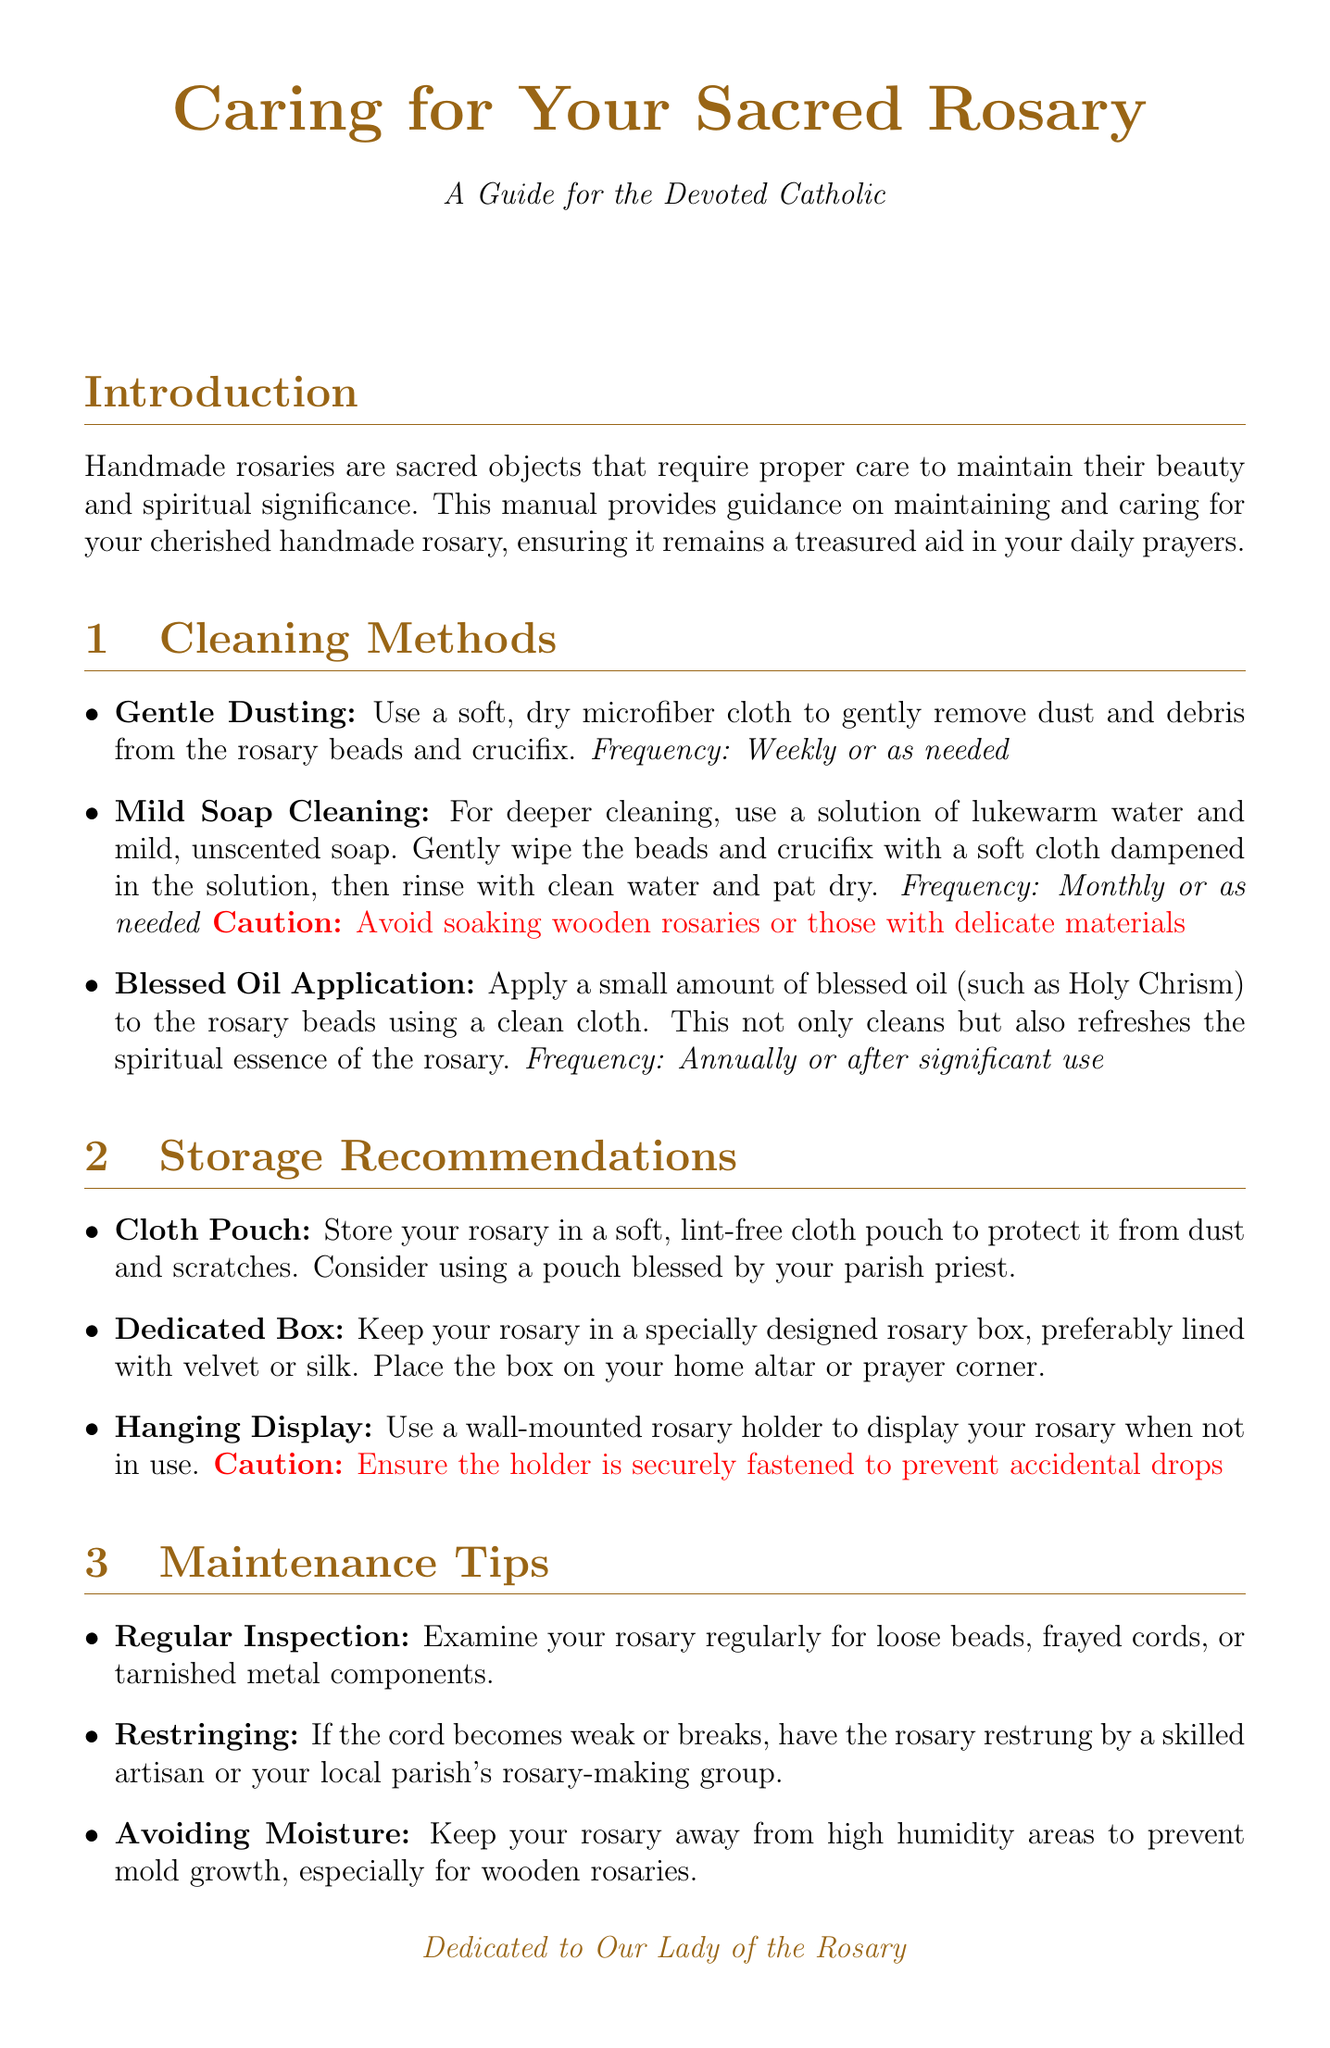What is the purpose of this manual? The purpose of the manual is to provide guidance on maintaining and caring for your cherished handmade rosary, ensuring it remains a treasured aid in your daily prayers.
Answer: To provide guidance on maintaining and caring for your cherished handmade rosary What is recommended for deeper cleaning? For deeper cleaning, the document suggests using a solution of lukewarm water and mild, unscented soap.
Answer: A solution of lukewarm water and mild, unscented soap How often should you apply blessed oil? Blessed oil should be applied annually or after significant use.
Answer: Annually or after significant use What is one method for storing a rosary? One method for storing a rosary is in a soft, lint-free cloth pouch.
Answer: In a soft, lint-free cloth pouch What is a maintenance tip regarding moisture? The document advises keeping the rosary away from high humidity areas to prevent mold growth.
Answer: Keep your rosary away from high humidity areas What should you do if the cord of the rosary breaks? You should have the rosary restrung by a skilled artisan or your local parish's rosary-making group.
Answer: Have the rosary restrung by a skilled artisan What is the significance of blessing renewal? The significance of blessing renewal is that it renews the spiritual potency of your rosary.
Answer: Renews the spiritual potency of your rosary What should you do during the cleaning routine? During the cleaning routine, it is suggested to incorporate prayer by reciting the Hail Mary or other devotions.
Answer: Incorporate prayer by reciting the Hail Mary or other devotions 